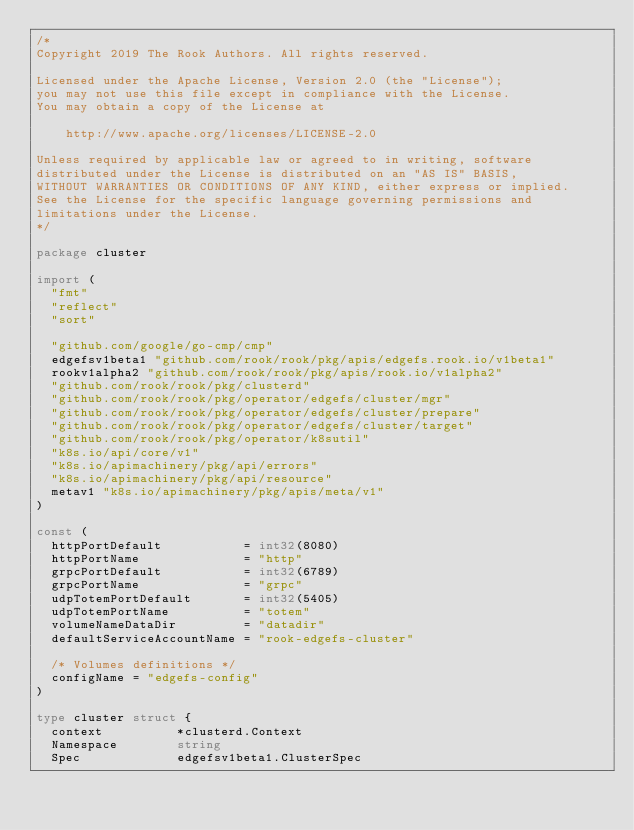<code> <loc_0><loc_0><loc_500><loc_500><_Go_>/*
Copyright 2019 The Rook Authors. All rights reserved.

Licensed under the Apache License, Version 2.0 (the "License");
you may not use this file except in compliance with the License.
You may obtain a copy of the License at

    http://www.apache.org/licenses/LICENSE-2.0

Unless required by applicable law or agreed to in writing, software
distributed under the License is distributed on an "AS IS" BASIS,
WITHOUT WARRANTIES OR CONDITIONS OF ANY KIND, either express or implied.
See the License for the specific language governing permissions and
limitations under the License.
*/

package cluster

import (
	"fmt"
	"reflect"
	"sort"

	"github.com/google/go-cmp/cmp"
	edgefsv1beta1 "github.com/rook/rook/pkg/apis/edgefs.rook.io/v1beta1"
	rookv1alpha2 "github.com/rook/rook/pkg/apis/rook.io/v1alpha2"
	"github.com/rook/rook/pkg/clusterd"
	"github.com/rook/rook/pkg/operator/edgefs/cluster/mgr"
	"github.com/rook/rook/pkg/operator/edgefs/cluster/prepare"
	"github.com/rook/rook/pkg/operator/edgefs/cluster/target"
	"github.com/rook/rook/pkg/operator/k8sutil"
	"k8s.io/api/core/v1"
	"k8s.io/apimachinery/pkg/api/errors"
	"k8s.io/apimachinery/pkg/api/resource"
	metav1 "k8s.io/apimachinery/pkg/apis/meta/v1"
)

const (
	httpPortDefault           = int32(8080)
	httpPortName              = "http"
	grpcPortDefault           = int32(6789)
	grpcPortName              = "grpc"
	udpTotemPortDefault       = int32(5405)
	udpTotemPortName          = "totem"
	volumeNameDataDir         = "datadir"
	defaultServiceAccountName = "rook-edgefs-cluster"

	/* Volumes definitions */
	configName = "edgefs-config"
)

type cluster struct {
	context          *clusterd.Context
	Namespace        string
	Spec             edgefsv1beta1.ClusterSpec</code> 